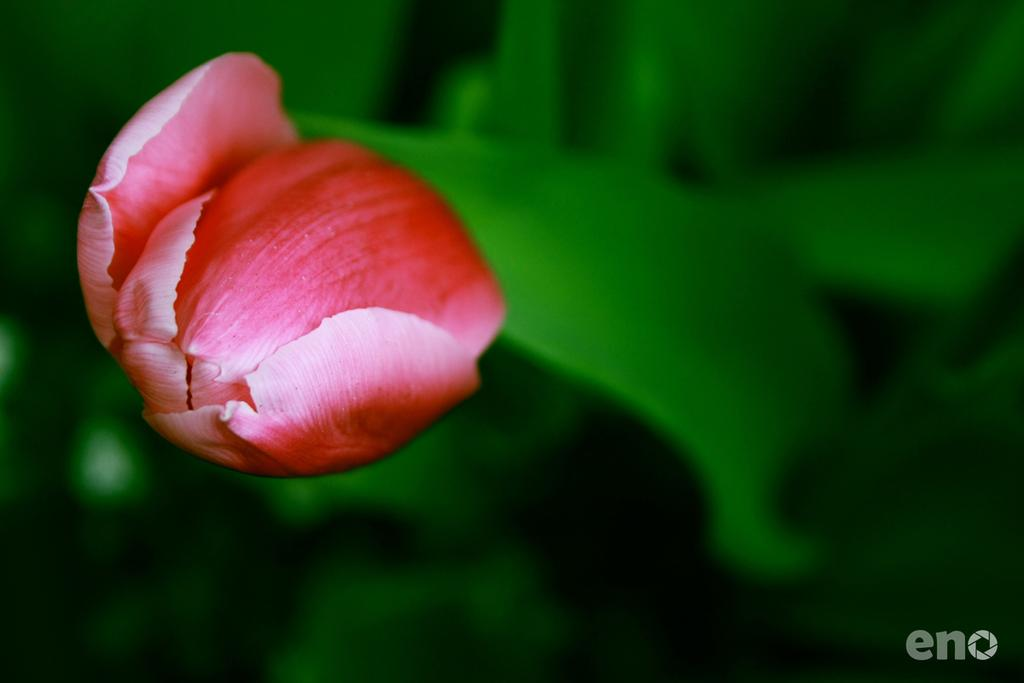What is the main subject of the image? There is a flower in the image. What color is the background of the image? The background of the image is green. Is there any additional information or branding on the image? Yes, there is a watermark on the image. How far away is the friend from the flower in the image? There is no friend present in the image, so it is not possible to determine the distance between them. 